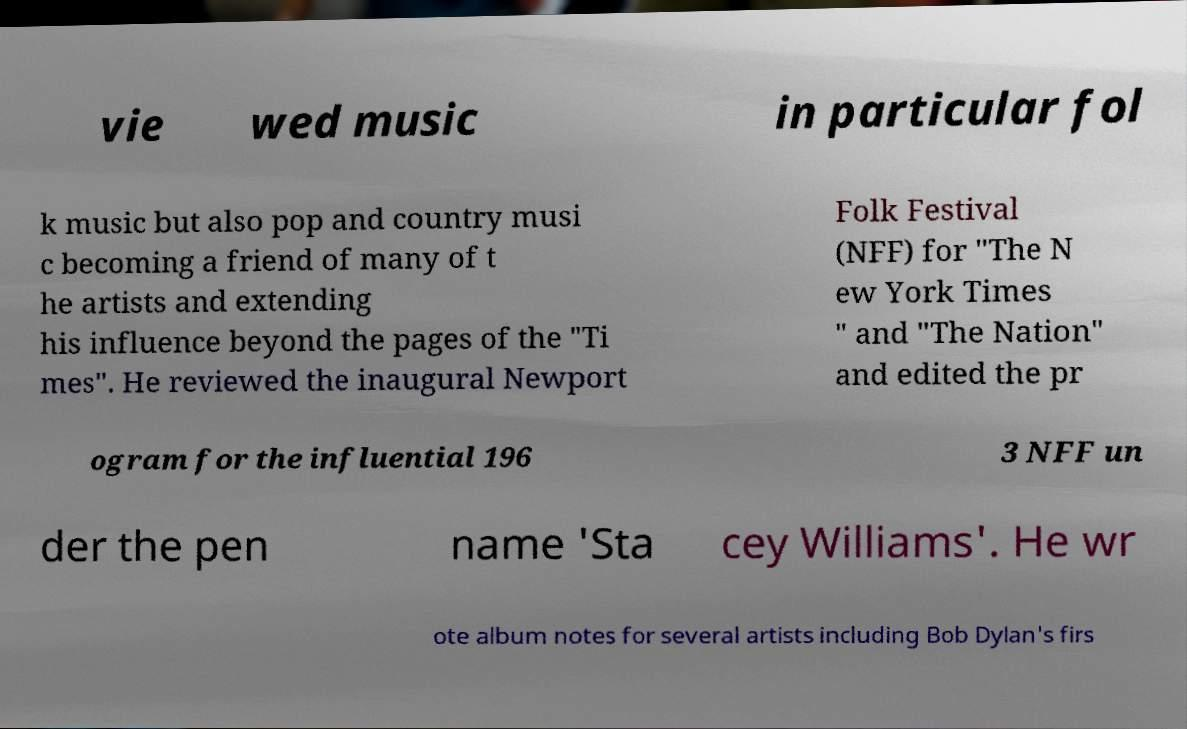Please read and relay the text visible in this image. What does it say? vie wed music in particular fol k music but also pop and country musi c becoming a friend of many of t he artists and extending his influence beyond the pages of the "Ti mes". He reviewed the inaugural Newport Folk Festival (NFF) for "The N ew York Times " and "The Nation" and edited the pr ogram for the influential 196 3 NFF un der the pen name 'Sta cey Williams'. He wr ote album notes for several artists including Bob Dylan's firs 